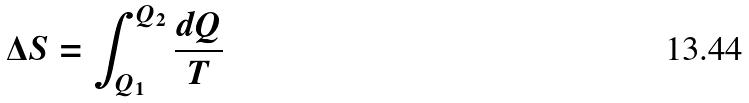Convert formula to latex. <formula><loc_0><loc_0><loc_500><loc_500>\Delta S = \int _ { Q _ { 1 } } ^ { Q _ { 2 } } \frac { d Q } { T }</formula> 